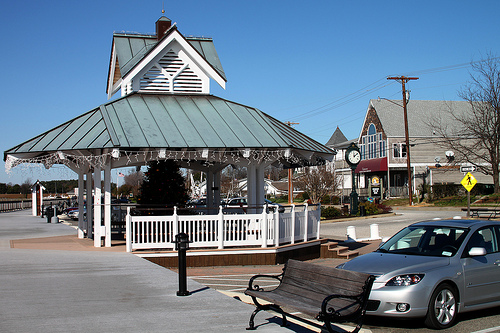Please provide the bounding box coordinate of the region this sentence describes: grey pointed roof. The bounding box coordinates for the grey pointed roof are approximately [0.65, 0.4, 0.72, 0.47]. These coordinates help identify the exact area of the image where this particular roof is located. 